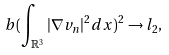<formula> <loc_0><loc_0><loc_500><loc_500>b ( \int _ { \mathbb { R } ^ { 3 } } | \nabla v _ { n } | ^ { 2 } d x ) ^ { 2 } \rightarrow l _ { 2 } ,</formula> 